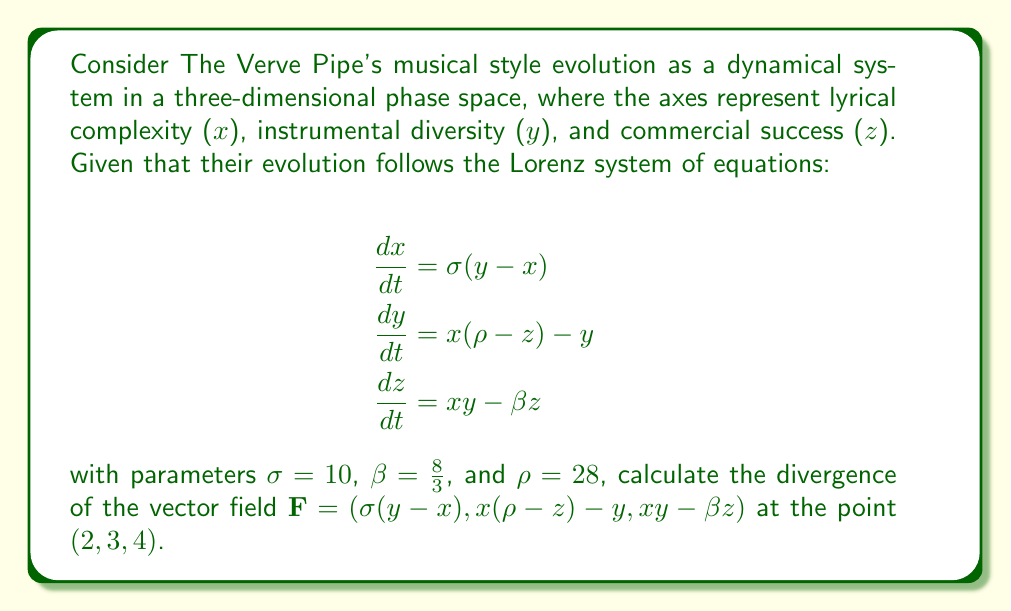Can you solve this math problem? To solve this problem, we need to follow these steps:

1. Recall that the divergence of a vector field $\mathbf{F}(x, y, z) = (F_1, F_2, F_3)$ is given by:

   $$\nabla \cdot \mathbf{F} = \frac{\partial F_1}{\partial x} + \frac{\partial F_2}{\partial y} + \frac{\partial F_3}{\partial z}$$

2. Identify the components of our vector field:
   $F_1 = \sigma(y-x)$
   $F_2 = x(\rho-z)-y$
   $F_3 = xy-\beta z$

3. Calculate the partial derivatives:

   $$\frac{\partial F_1}{\partial x} = -\sigma = -10$$
   
   $$\frac{\partial F_2}{\partial y} = -1$$
   
   $$\frac{\partial F_3}{\partial z} = -\beta = -\frac{8}{3}$$

4. Sum the partial derivatives:

   $$\nabla \cdot \mathbf{F} = -\sigma - 1 - \beta = -10 - 1 - \frac{8}{3}$$

5. Simplify:

   $$\nabla \cdot \mathbf{F} = -11 - \frac{8}{3} = -\frac{41}{3}$$

Note that this result is constant and doesn't depend on the specific point $(2, 3, 4)$. This is a characteristic of the Lorenz system.
Answer: $-\frac{41}{3}$ 